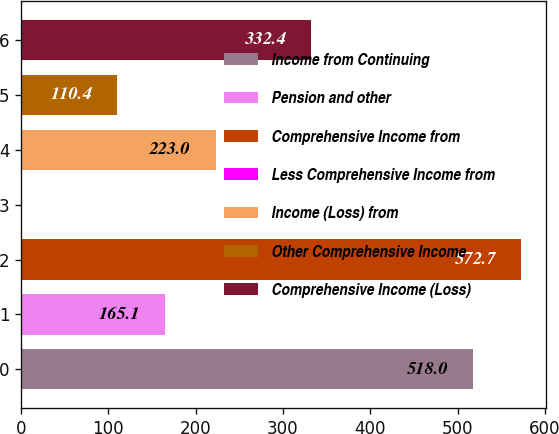<chart> <loc_0><loc_0><loc_500><loc_500><bar_chart><fcel>Income from Continuing<fcel>Pension and other<fcel>Comprehensive Income from<fcel>Less Comprehensive Income from<fcel>Income (Loss) from<fcel>Other Comprehensive Income<fcel>Comprehensive Income (Loss)<nl><fcel>518<fcel>165.1<fcel>572.7<fcel>1<fcel>223<fcel>110.4<fcel>332.4<nl></chart> 